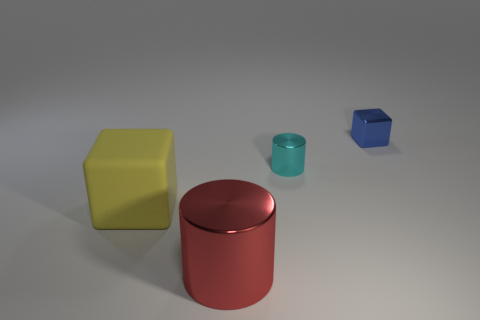Add 1 large metal cylinders. How many objects exist? 5 Subtract all big red cylinders. Subtract all big matte objects. How many objects are left? 2 Add 1 large red shiny cylinders. How many large red shiny cylinders are left? 2 Add 2 large red things. How many large red things exist? 3 Subtract 0 yellow spheres. How many objects are left? 4 